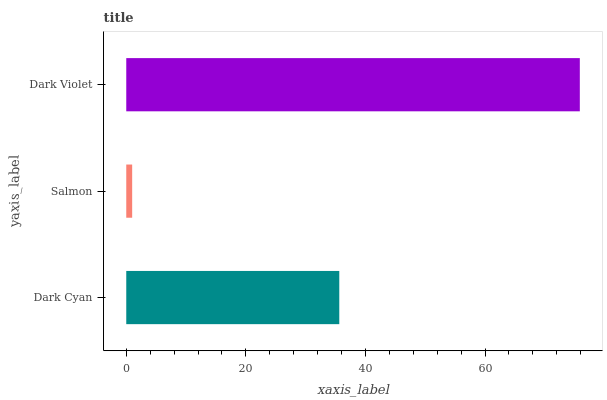Is Salmon the minimum?
Answer yes or no. Yes. Is Dark Violet the maximum?
Answer yes or no. Yes. Is Dark Violet the minimum?
Answer yes or no. No. Is Salmon the maximum?
Answer yes or no. No. Is Dark Violet greater than Salmon?
Answer yes or no. Yes. Is Salmon less than Dark Violet?
Answer yes or no. Yes. Is Salmon greater than Dark Violet?
Answer yes or no. No. Is Dark Violet less than Salmon?
Answer yes or no. No. Is Dark Cyan the high median?
Answer yes or no. Yes. Is Dark Cyan the low median?
Answer yes or no. Yes. Is Dark Violet the high median?
Answer yes or no. No. Is Salmon the low median?
Answer yes or no. No. 